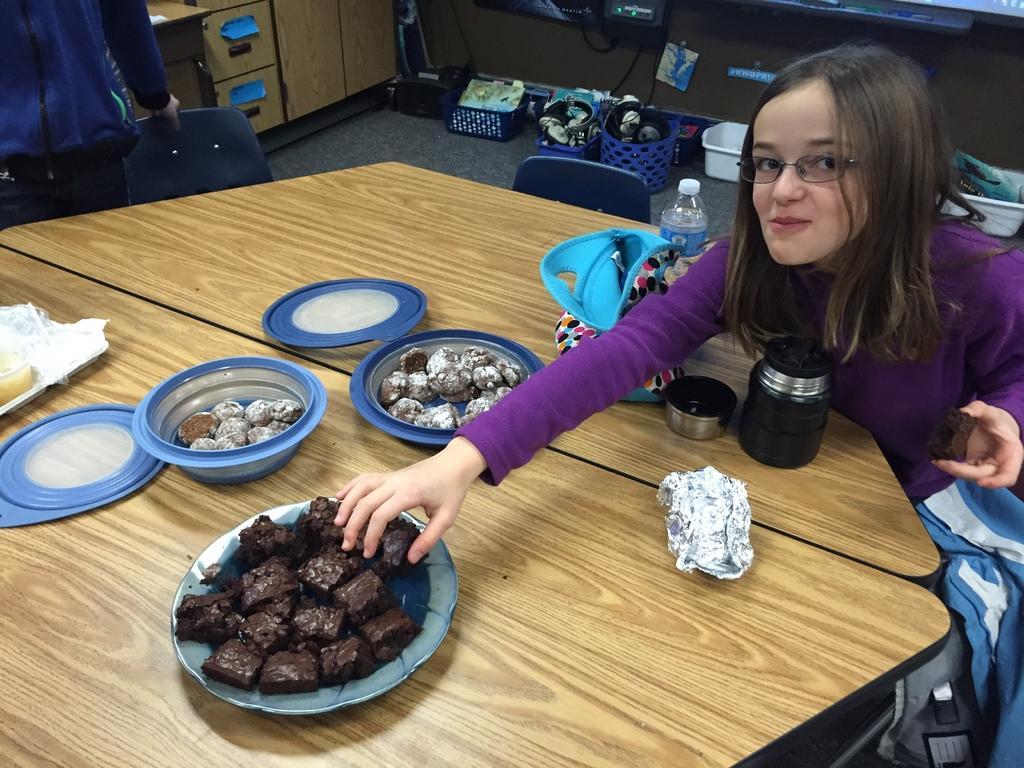Describe this image in one or two sentences. In this image I can see two tables and on these tables I can see two boxes, two plates, a bag, a bottle, a jar, an aluminium foil, a glass and different types of food. On the right side of the image I can see a girl and I can see she is holding food. I can also see she is wearing a specs and purple colour dress. In the background I can see number of blue colour baskets, few white colour containers, few drawers and few other stuffs. I can also see one person and a chair on the top left side. 